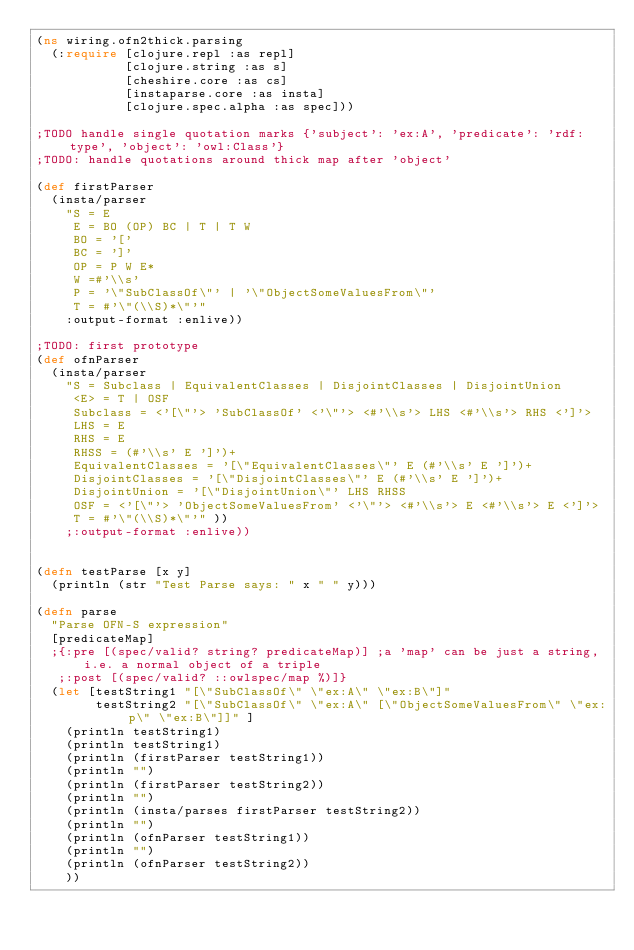Convert code to text. <code><loc_0><loc_0><loc_500><loc_500><_Clojure_>(ns wiring.ofn2thick.parsing
  (:require [clojure.repl :as repl]
            [clojure.string :as s]
            [cheshire.core :as cs]
            [instaparse.core :as insta]
            [clojure.spec.alpha :as spec]))

;TODO handle single quotation marks {'subject': 'ex:A', 'predicate': 'rdf:type', 'object': 'owl:Class'} 
;TODO: handle quotations around thick map after 'object' 

(def firstParser
  (insta/parser
    "S = E
     E = BO (OP) BC | T | T W
     BO = '['
     BC = ']'
     OP = P W E*
     W =#'\\s'
     P = '\"SubClassOf\"' | '\"ObjectSomeValuesFrom\"'
     T = #'\"(\\S)*\"'"
    :output-format :enlive))

;TODO: first prototype
(def ofnParser
  (insta/parser
    "S = Subclass | EquivalentClasses | DisjointClasses | DisjointUnion
     <E> = T | OSF
     Subclass = <'[\"'> 'SubClassOf' <'\"'> <#'\\s'> LHS <#'\\s'> RHS <']'>
     LHS = E
     RHS = E
     RHSS = (#'\\s' E ']')+
     EquivalentClasses = '[\"EquivalentClasses\"' E (#'\\s' E ']')+
     DisjointClasses = '[\"DisjointClasses\"' E (#'\\s' E ']')+
     DisjointUnion = '[\"DisjointUnion\"' LHS RHSS
     OSF = <'[\"'> 'ObjectSomeValuesFrom' <'\"'> <#'\\s'> E <#'\\s'> E <']'>
     T = #'\"(\\S)*\"'" ))
    ;:output-format :enlive))


(defn testParse [x y]
  (println (str "Test Parse says: " x " " y)))

(defn parse
  "Parse OFN-S expression"
  [predicateMap]
  ;{:pre [(spec/valid? string? predicateMap)] ;a 'map' can be just a string, i.e. a normal object of a triple
   ;:post [(spec/valid? ::owlspec/map %)]}
  (let [testString1 "[\"SubClassOf\" \"ex:A\" \"ex:B\"]"
        testString2 "[\"SubClassOf\" \"ex:A\" [\"ObjectSomeValuesFrom\" \"ex:p\" \"ex:B\"]]" ]
    (println testString1)
    (println testString1)
    (println (firstParser testString1)) 
    (println "")
    (println (firstParser testString2)) 
    (println "")
    (println (insta/parses firstParser testString2)) 
    (println "")
    (println (ofnParser testString1)) 
    (println "")
    (println (ofnParser testString2)) 
    ))
</code> 